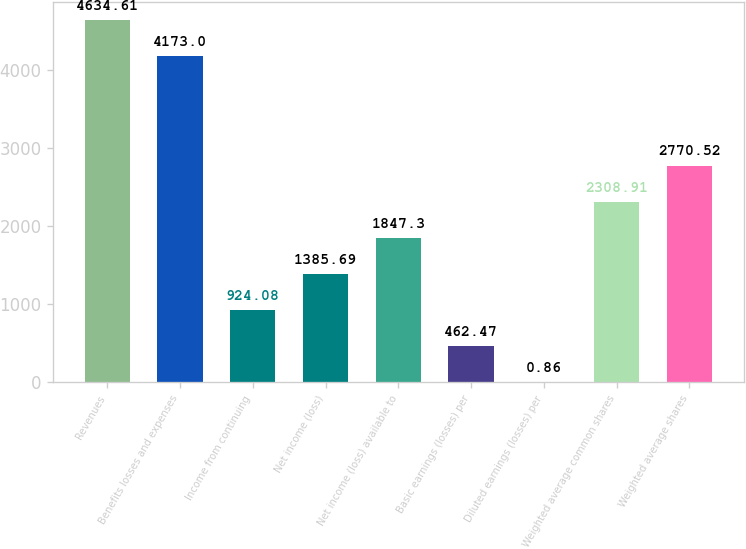Convert chart to OTSL. <chart><loc_0><loc_0><loc_500><loc_500><bar_chart><fcel>Revenues<fcel>Benefits losses and expenses<fcel>Income from continuing<fcel>Net income (loss)<fcel>Net income (loss) available to<fcel>Basic earnings (losses) per<fcel>Diluted earnings (losses) per<fcel>Weighted average common shares<fcel>Weighted average shares<nl><fcel>4634.61<fcel>4173<fcel>924.08<fcel>1385.69<fcel>1847.3<fcel>462.47<fcel>0.86<fcel>2308.91<fcel>2770.52<nl></chart> 